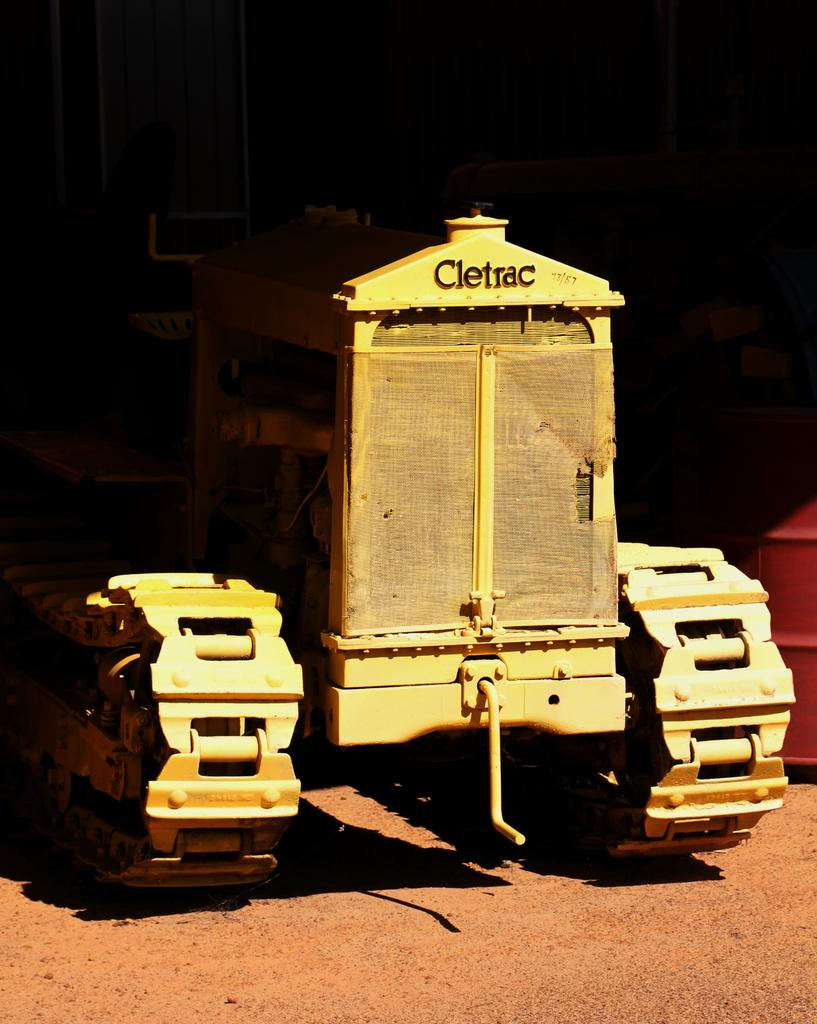What is the main subject in the foreground of the image? There is a vehicle in the foreground of the image. Can you describe the position of the vehicle in the image? The vehicle is on the ground. What can be seen in the background of the image? There are objects visible in the background of the image. How would you describe the color of the background? The background has a dark color. Based on the visibility of the objects and the color of the background, can you make an assumption about the time of day the image might have been taken? The image might have been taken during the day. What type of arch can be seen in the image? There is no arch present in the image. Can you describe the tree that is visible in the image? There is no tree visible in the image. 